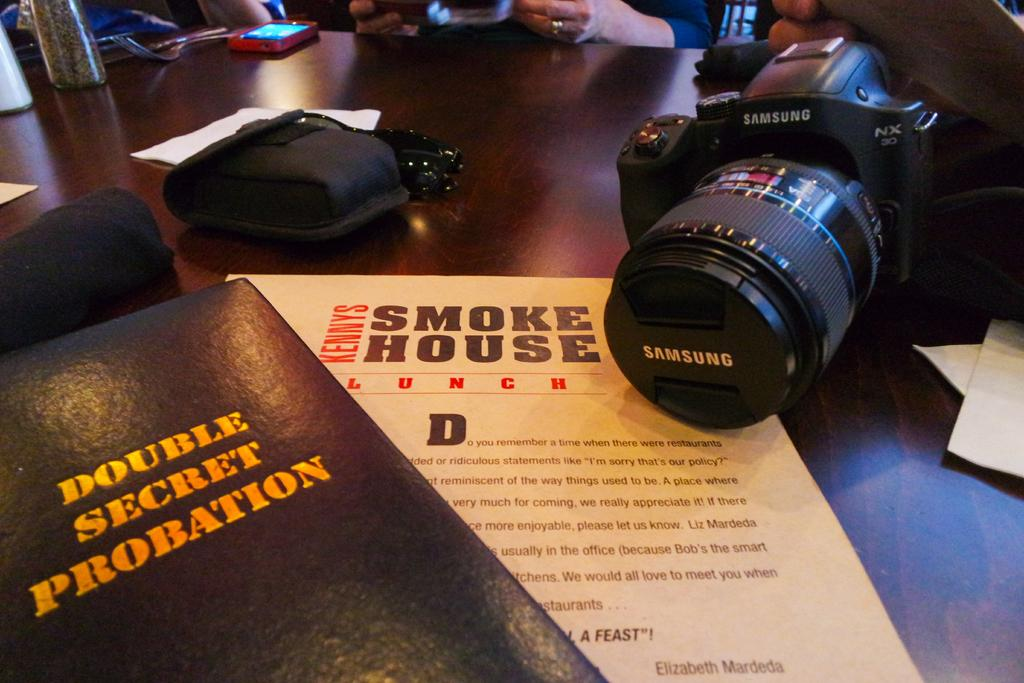What is the main object in the center of the image? There is a table in the center of the image. What items can be seen on the table? Papers, a camera, and goggles are on the table. Are there any other objects on the table? Yes, there are other objects on the table. Can you describe the people in the background of the image? There are people in the background of the image, but their specific characteristics are not mentioned in the facts. What type of bird is sitting on the camera in the image? There is no bird present on the camera or in the image. 